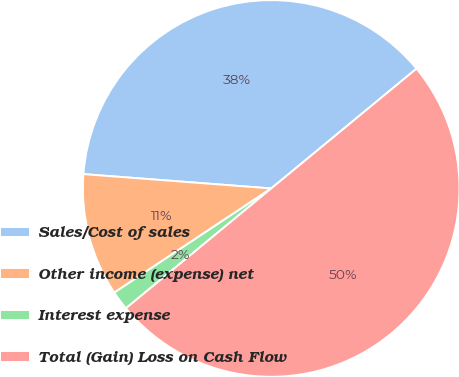Convert chart to OTSL. <chart><loc_0><loc_0><loc_500><loc_500><pie_chart><fcel>Sales/Cost of sales<fcel>Other income (expense) net<fcel>Interest expense<fcel>Total (Gain) Loss on Cash Flow<nl><fcel>37.81%<fcel>10.54%<fcel>1.65%<fcel>50.0%<nl></chart> 